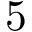<formula> <loc_0><loc_0><loc_500><loc_500>5</formula> 